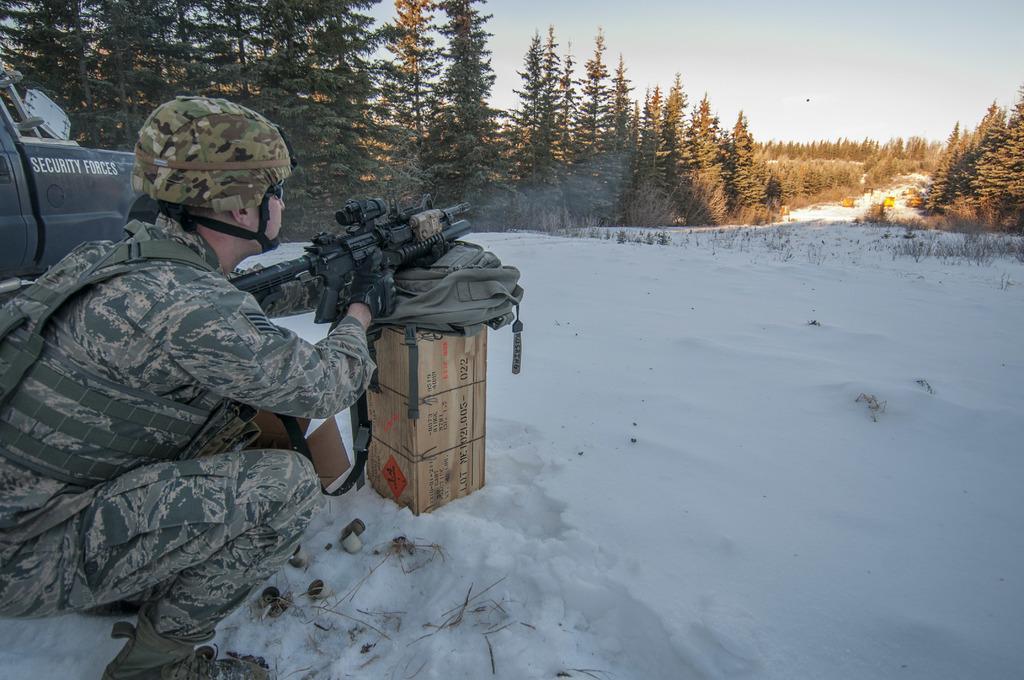In one or two sentences, can you explain what this image depicts? In this picture there is a soldier on the left side of the image, by holding a gun in his hands and there is a jeep behind him, there is snow in the center of the image and there are trees in the background area of the image. 